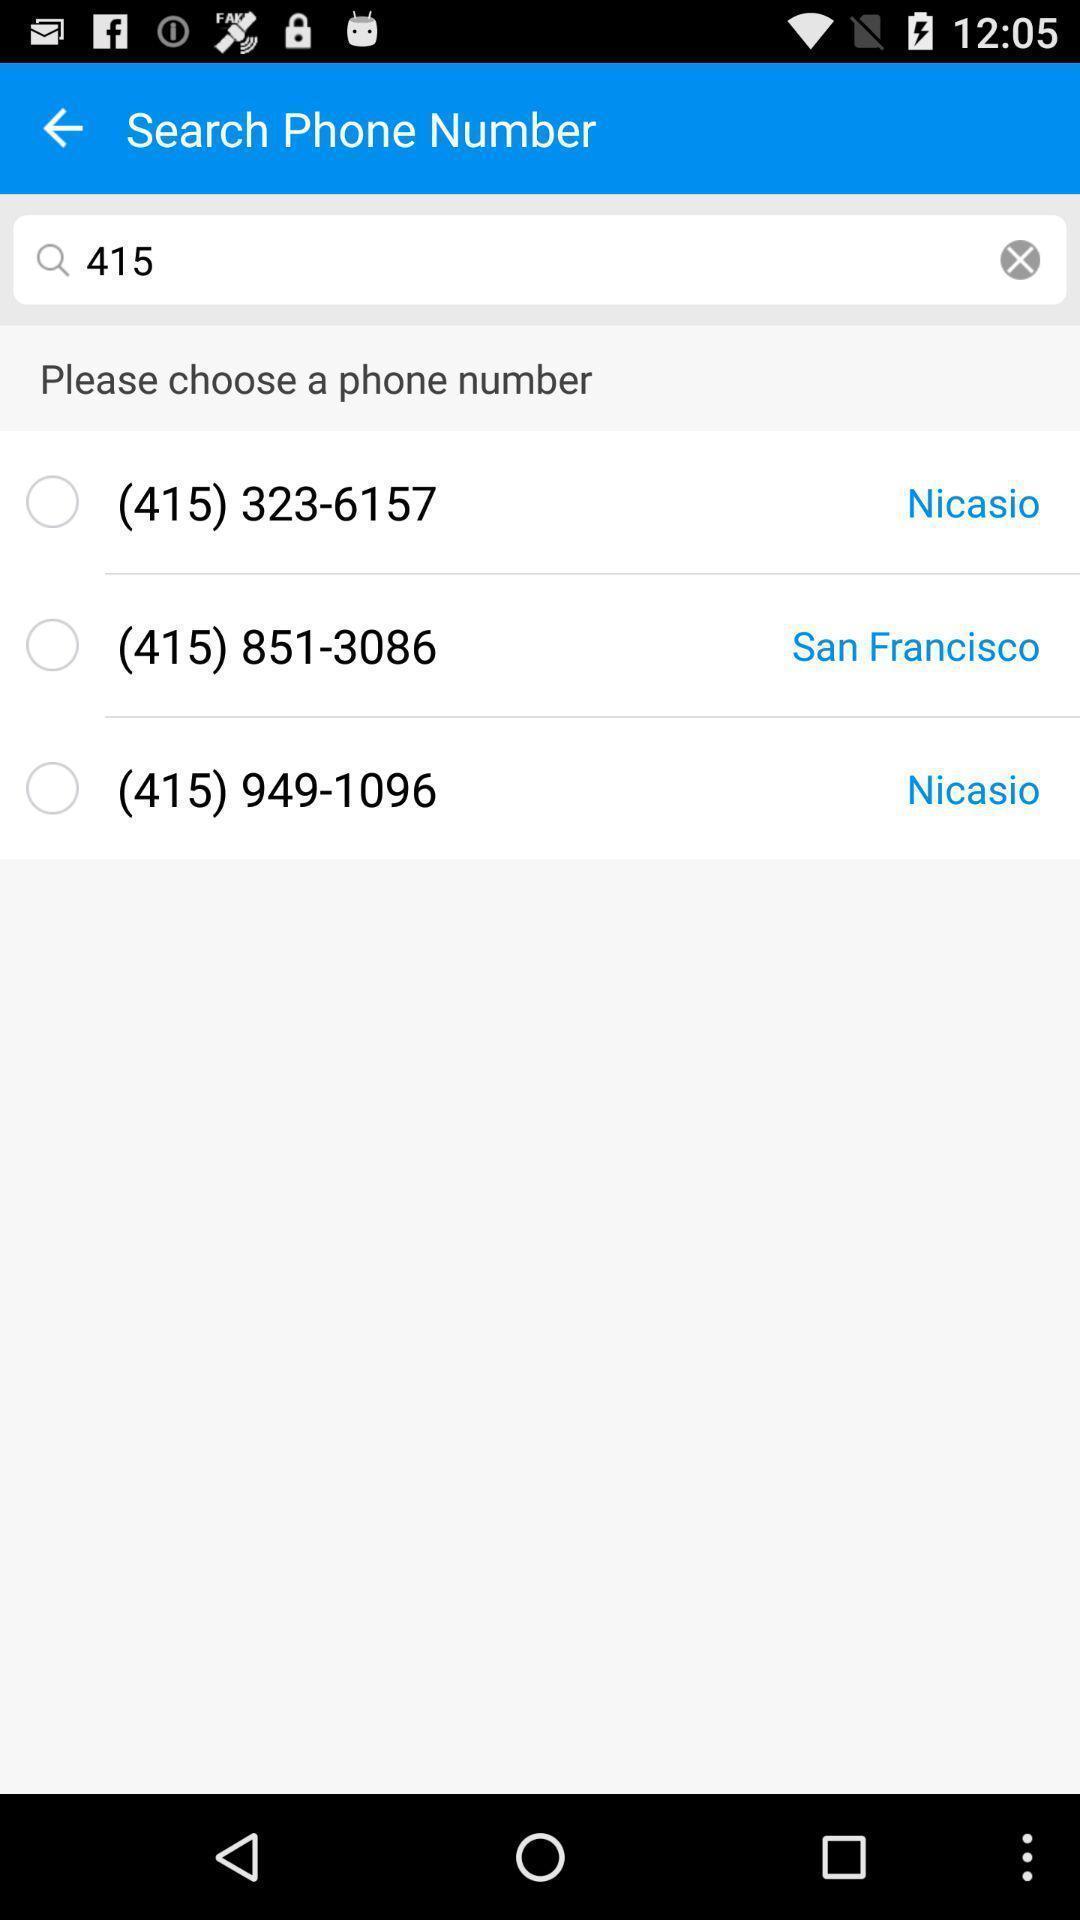Summarize the information in this screenshot. Search contacts page with search box and list of contacts. 